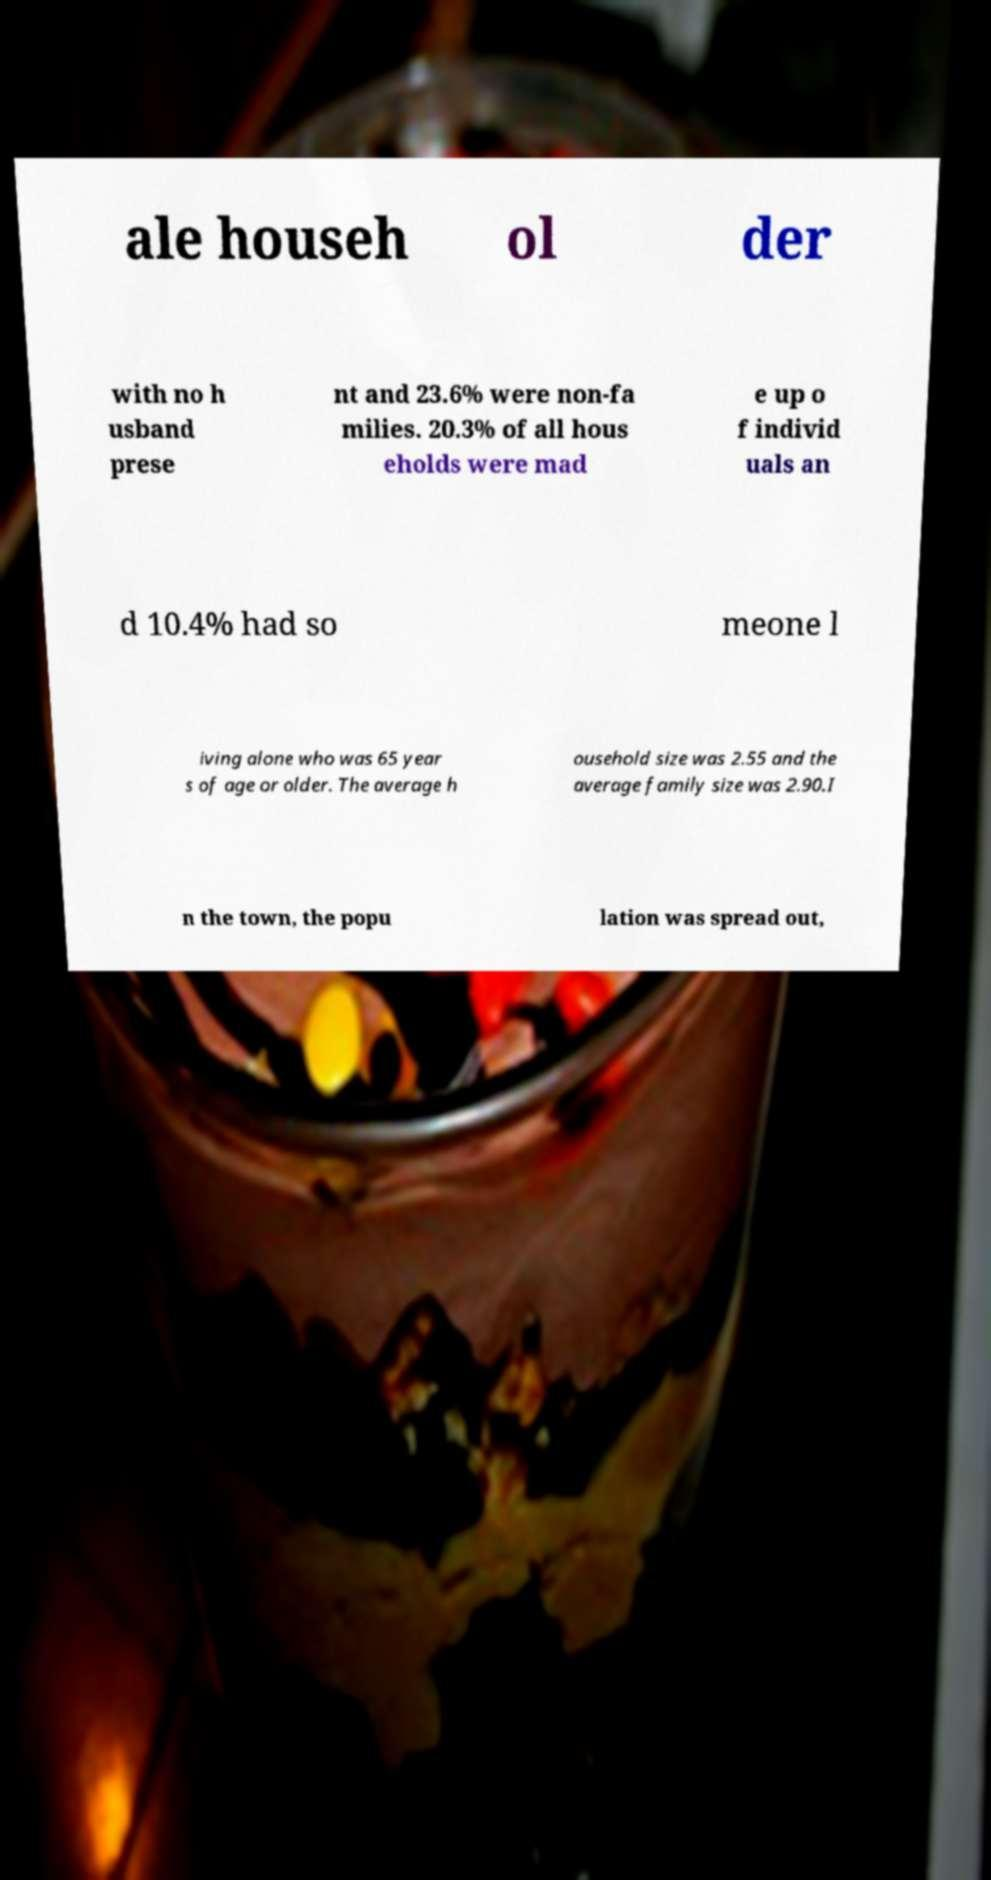What messages or text are displayed in this image? I need them in a readable, typed format. ale househ ol der with no h usband prese nt and 23.6% were non-fa milies. 20.3% of all hous eholds were mad e up o f individ uals an d 10.4% had so meone l iving alone who was 65 year s of age or older. The average h ousehold size was 2.55 and the average family size was 2.90.I n the town, the popu lation was spread out, 